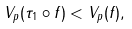Convert formula to latex. <formula><loc_0><loc_0><loc_500><loc_500>V _ { p } ( \tau _ { 1 } \circ f ) < V _ { p } ( f ) ,</formula> 